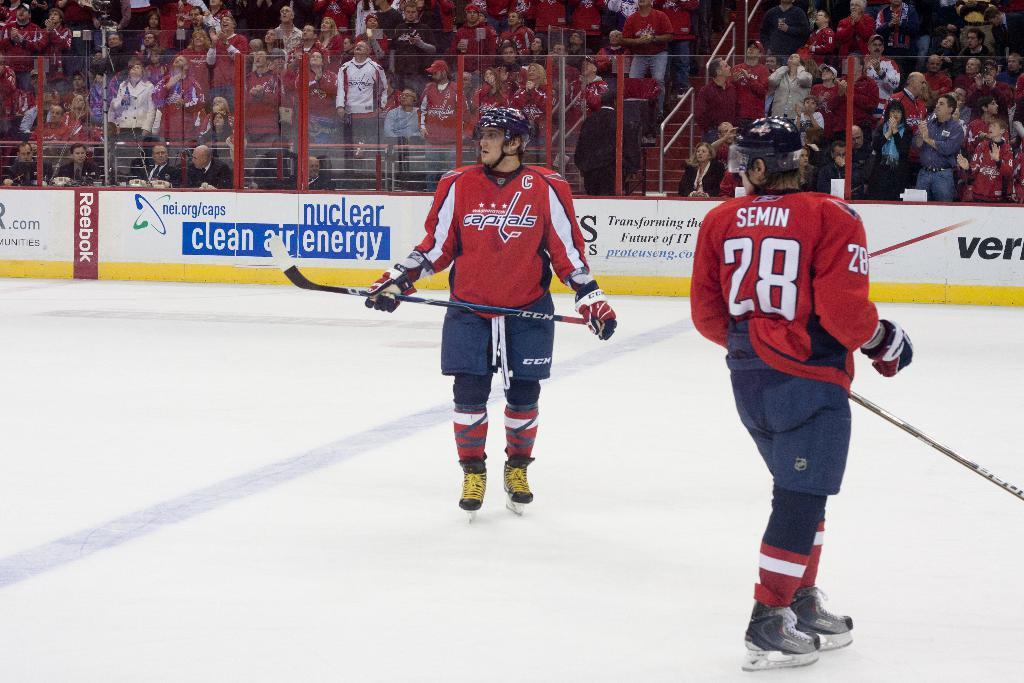How many men are in the image? There are two men in the image. What are the men wearing? The men are wearing red dress, likely red jerseys. What surface are the men standing on? The men are standing on an ice floor. What objects are the men holding? The men are holding hockey sticks. What can be seen in the background of the image? There are many people sitting in the back of the image. What are the seated people sitting on? The people are sitting on chairs. What is in front of the seated people? There is a fence in front of front of the seated people. What type of lunchroom is visible in the image? There is no lunchroom present in the image. The image features two men on an ice floor, holding hockey sticks, and a group of seated people with a fence in front of them. 